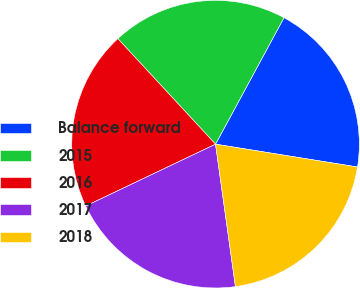<chart> <loc_0><loc_0><loc_500><loc_500><pie_chart><fcel>Balance forward<fcel>2015<fcel>2016<fcel>2017<fcel>2018<nl><fcel>19.64%<fcel>19.78%<fcel>20.19%<fcel>20.13%<fcel>20.25%<nl></chart> 